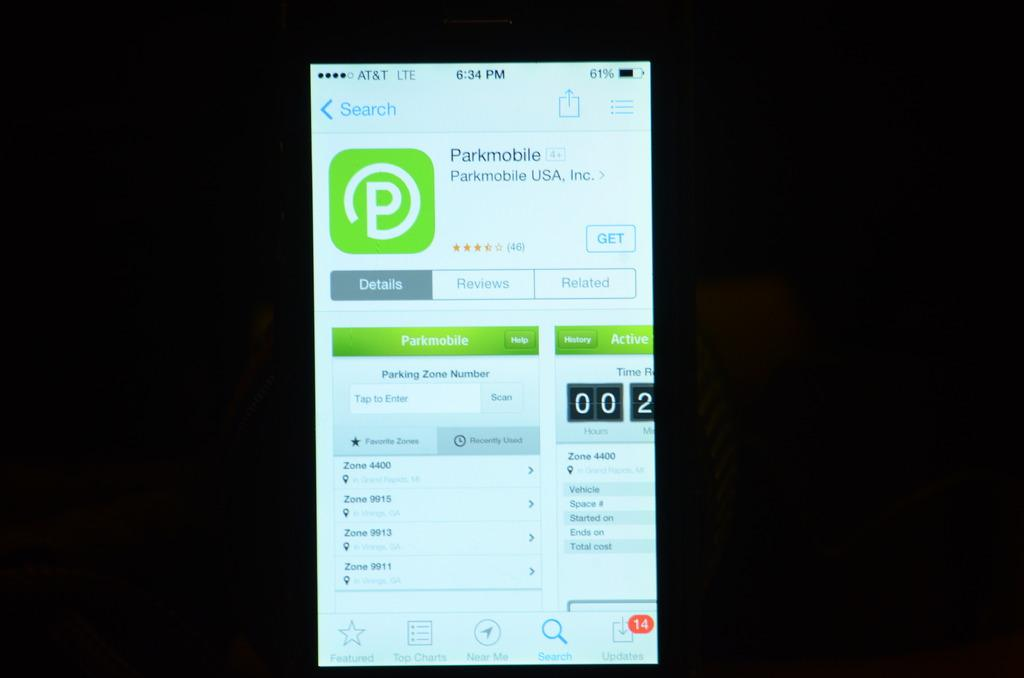<image>
Create a compact narrative representing the image presented. A display screen showing the icon and name of Parkmobile USA, Inc. 